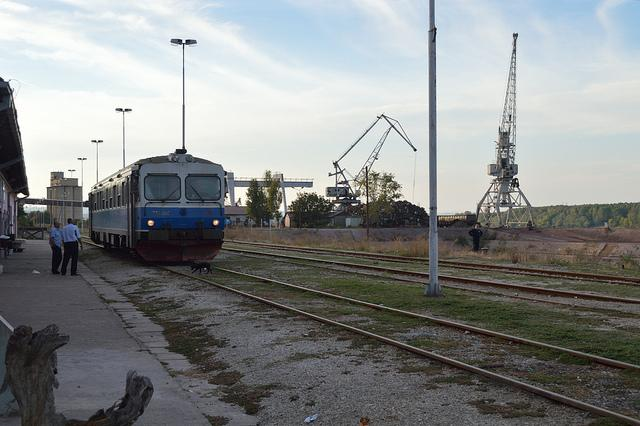Which entity is in the greatest danger? people 